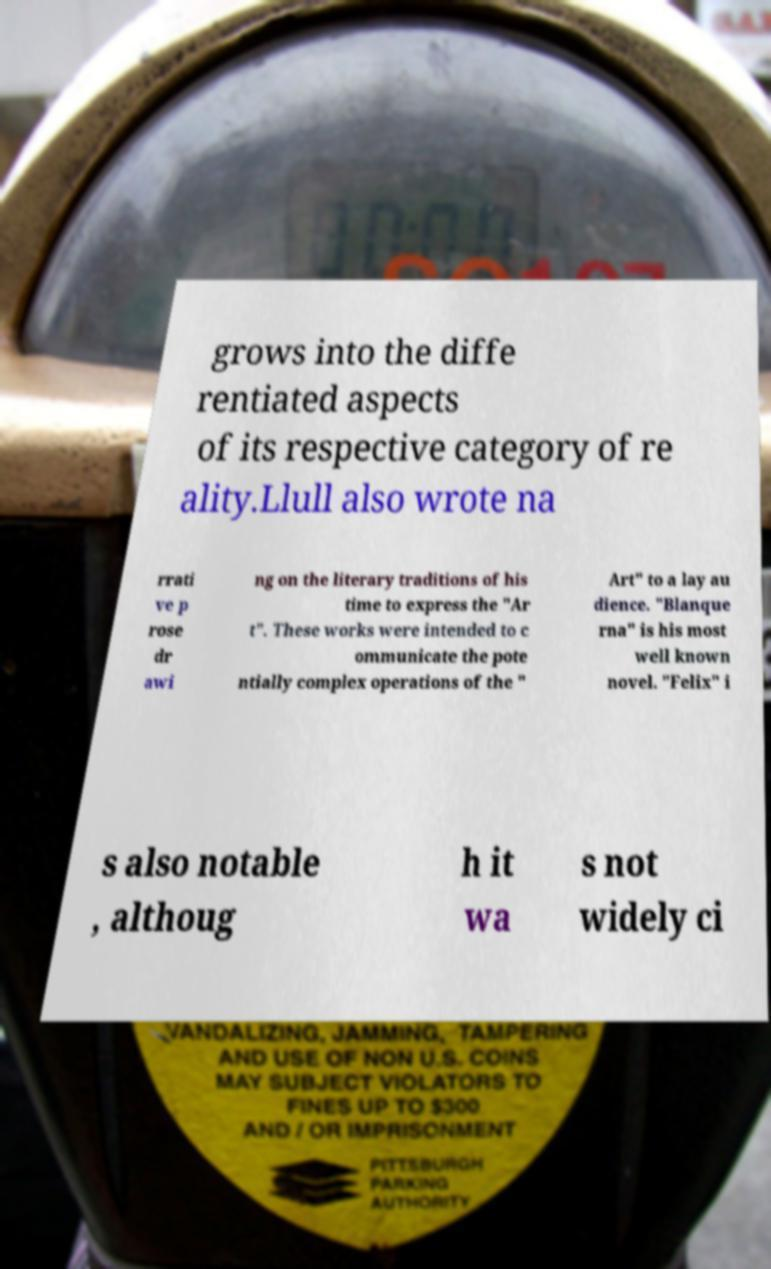There's text embedded in this image that I need extracted. Can you transcribe it verbatim? grows into the diffe rentiated aspects of its respective category of re ality.Llull also wrote na rrati ve p rose dr awi ng on the literary traditions of his time to express the "Ar t". These works were intended to c ommunicate the pote ntially complex operations of the " Art" to a lay au dience. "Blanque rna" is his most well known novel. "Felix" i s also notable , althoug h it wa s not widely ci 